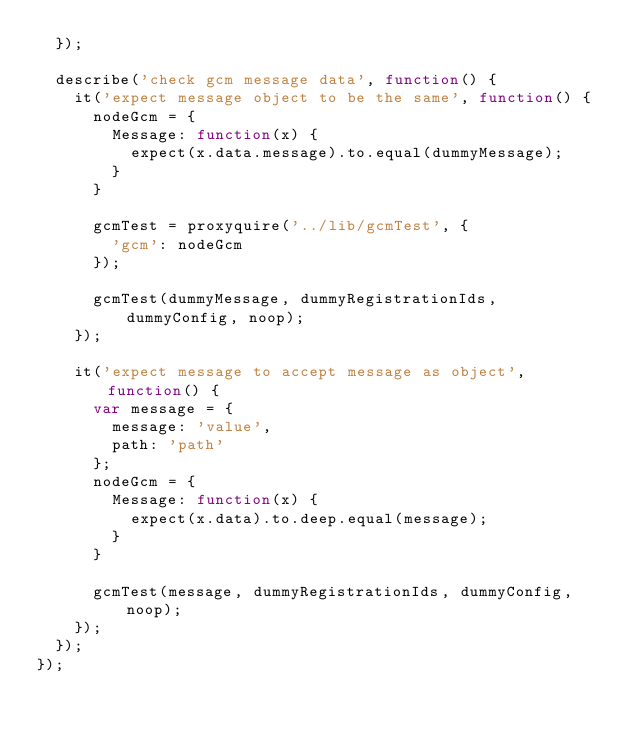Convert code to text. <code><loc_0><loc_0><loc_500><loc_500><_JavaScript_>  });

  describe('check gcm message data', function() {
    it('expect message object to be the same', function() {
      nodeGcm = {
        Message: function(x) {
          expect(x.data.message).to.equal(dummyMessage);
        }
      }

      gcmTest = proxyquire('../lib/gcmTest', {
        'gcm': nodeGcm
      });

      gcmTest(dummyMessage, dummyRegistrationIds, dummyConfig, noop);
    });

    it('expect message to accept message as object', function() {
      var message = {
        message: 'value',
        path: 'path'
      };
      nodeGcm = {
        Message: function(x) {
          expect(x.data).to.deep.equal(message);
        }
      }

      gcmTest(message, dummyRegistrationIds, dummyConfig, noop);
    });
  });
});
</code> 